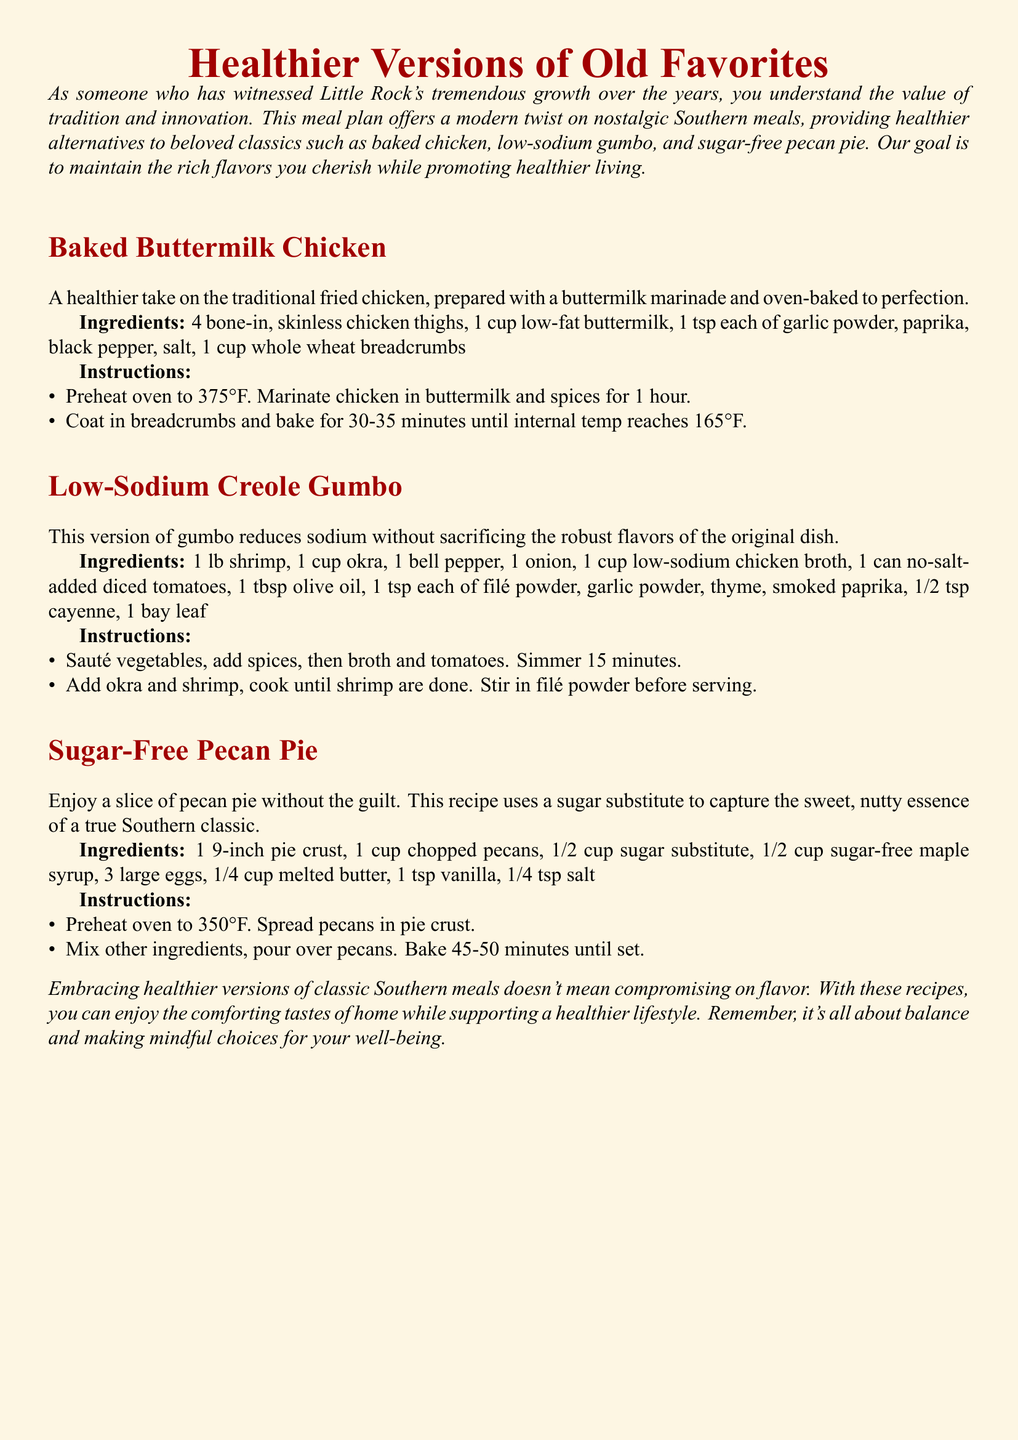What is the first recipe listed? The first recipe listed in the document is Baked Buttermilk Chicken.
Answer: Baked Buttermilk Chicken How many chicken thighs are needed for the Baked Buttermilk Chicken? The recipe for Baked Buttermilk Chicken requires 4 bone-in, skinless chicken thighs.
Answer: 4 What is used as a sugar substitute in the Sugar-Free Pecan Pie? The recipe specifies using a sugar substitute along with sugar-free maple syrup for sweetness.
Answer: Sugar substitute At what temperature should the oven be preheated for the Sugar-Free Pecan Pie? The document states that the oven should be preheated to 350°F for the Sugar-Free Pecan Pie.
Answer: 350°F What is the main ingredient in the Low-Sodium Creole Gumbo? The main ingredient in the Low-Sodium Creole Gumbo is shrimp.
Answer: Shrimp How many minutes should the baked chicken be cooked? The chicken should be baked for 30-35 minutes until an internal temperature of 165°F is reached.
Answer: 30-35 minutes What ingredient is added before serving the Low-Sodium Creole Gumbo? Filé powder is stirred in before serving the Low-Sodium Creole Gumbo.
Answer: Filé powder What is the purpose of this meal plan? The purpose of the meal plan is to offer healthier alternatives to beloved Southern classics while maintaining the flavors.
Answer: Healthier alternatives 